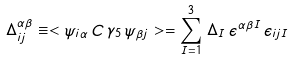<formula> <loc_0><loc_0><loc_500><loc_500>\Delta _ { i j } ^ { \alpha \beta } \equiv < \psi _ { i \alpha } \, C \, \gamma _ { 5 } \, \psi _ { \beta j } > = \sum _ { I = 1 } ^ { 3 } \, \Delta _ { I } \, \epsilon ^ { \alpha \beta I } \, \epsilon _ { i j I }</formula> 